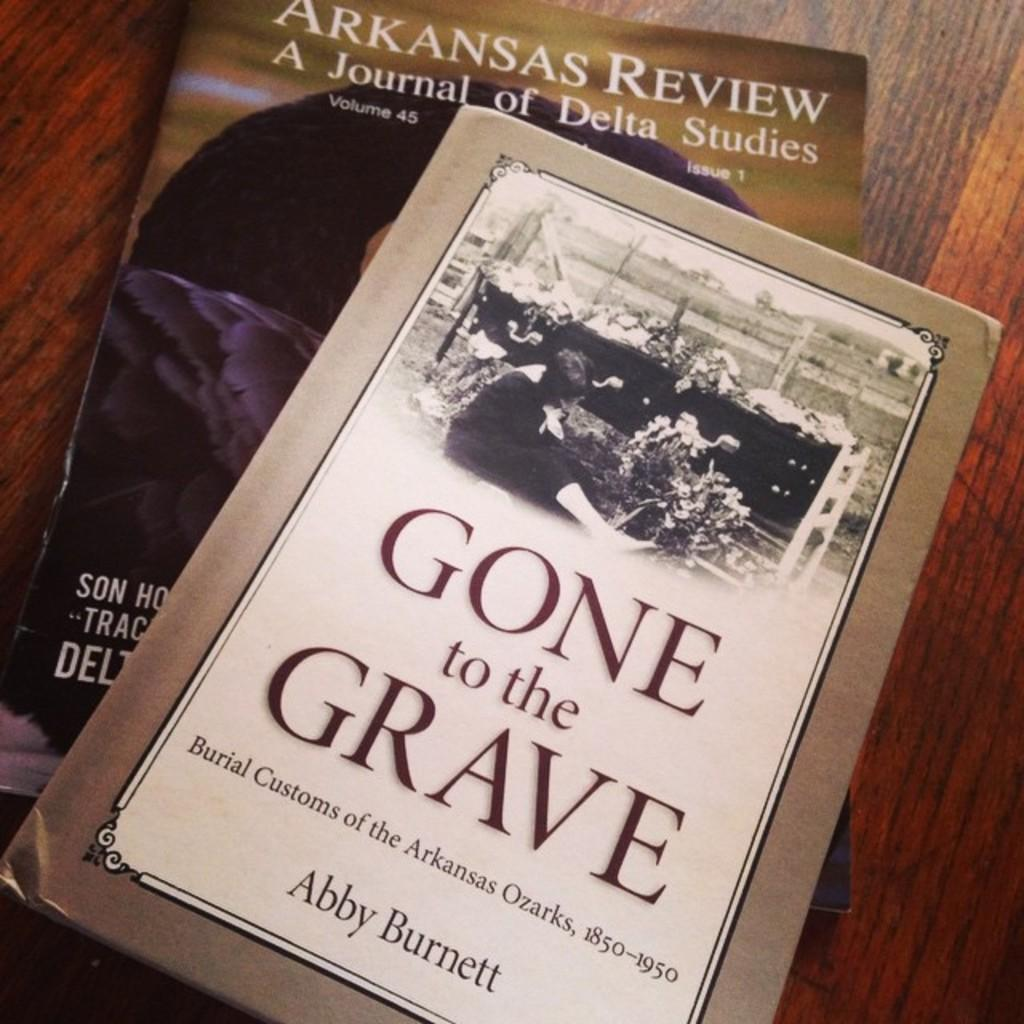What objects are on the table in the image? There are two books on the table in the image. What can be seen on the books? Both books have text on them, and one book has a picture of a person sitting. Can you describe the other unspecified things visible in the image? Unfortunately, the provided facts do not specify what these other things are. How many hands are visible in the image? There is no mention of hands in the provided facts, so we cannot determine if any are visible in the image. 